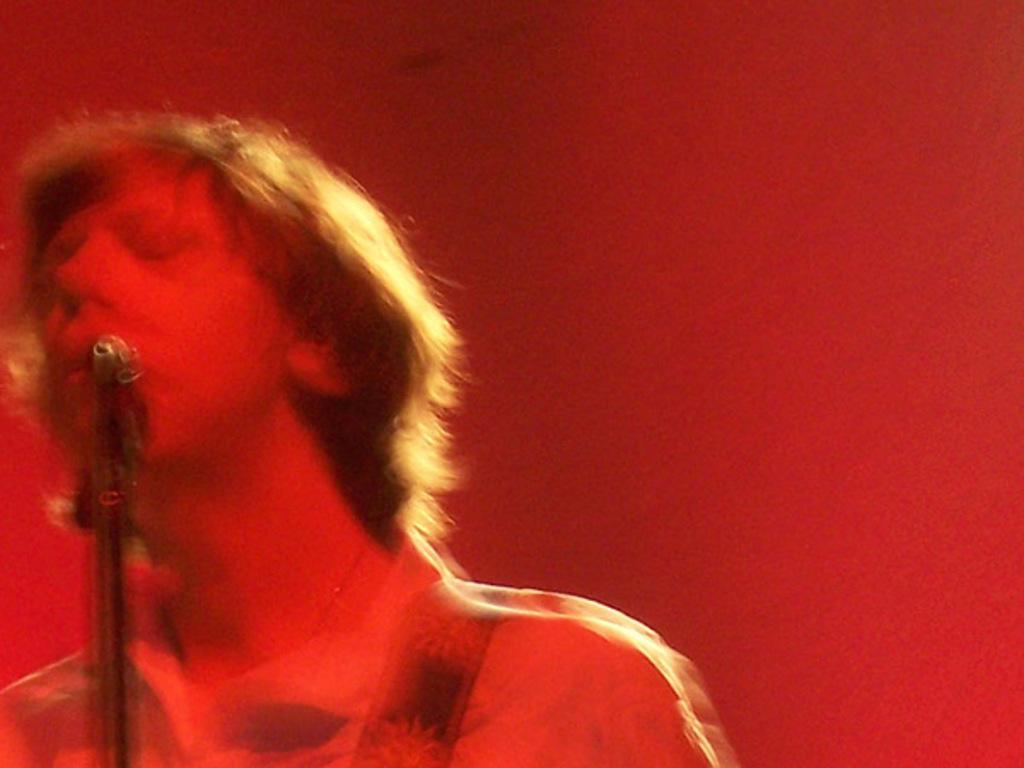Please provide a concise description of this image. In this picture I can see a person in front of a tripod. I see that this image is little bit in red color. 